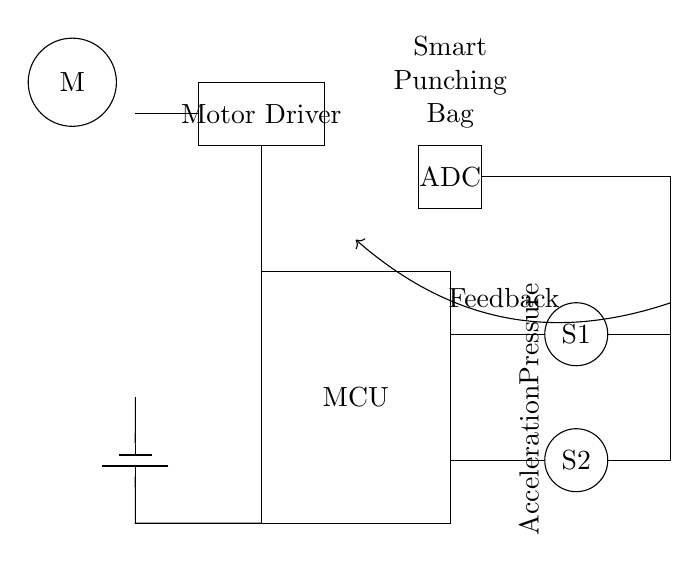What is the main component of this circuit? The main component is the microcontroller, which is labeled as "MCU" in the diagram. It serves as the central unit that processes the input from the sensors.
Answer: MCU How many sensors are present in the circuit? There are two sensors labeled as S1 and S2 in the diagram. They are responsible for collecting data related to pressure and acceleration.
Answer: 2 What does the ADC stand for in this circuit? The ADC stands for Analog-to-Digital Converter. It converts the analog signals from the sensors into digital signals that the microcontroller can process.
Answer: Analog-to-Digital Converter What type of feedback is indicated in the circuit? The feedback is labeled simply as "Feedback" and it is directed from the sensors back to the microcontroller, indicating a loop for processing the sensor data.
Answer: Feedback What is the role of the Motor Driver in this circuit? The Motor Driver controls the power supplied to the motor based on the processed signals from the microcontroller, allowing it to respond effectively during operation.
Answer: Control motor power How is the power supplied to the circuit? The power is supplied by a battery, as indicated by the battery symbol connected to the MCU, providing the necessary voltage for the circuit to operate.
Answer: Battery What does the diagram indicate about the punching bag? The diagram shows that the smart punching bag is equipped with sensors to give real-time feedback and adjust the motor's response depending on the interactions detected.
Answer: Smart punching bag 